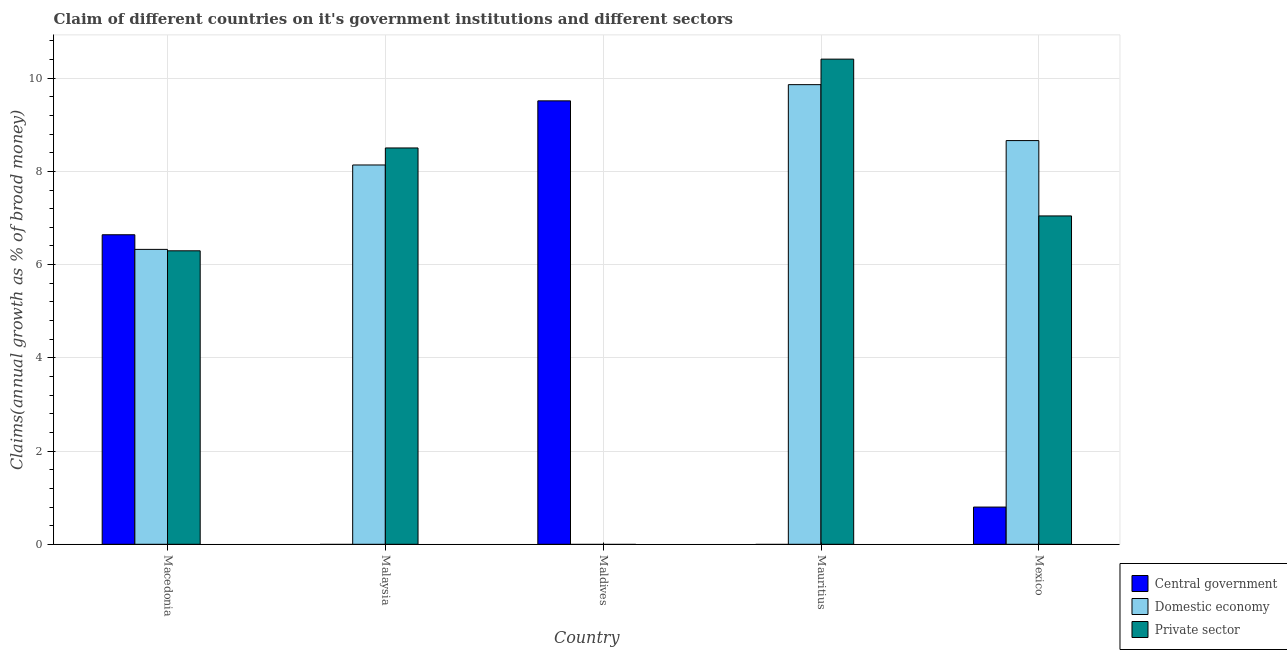Are the number of bars per tick equal to the number of legend labels?
Your answer should be very brief. No. How many bars are there on the 1st tick from the left?
Provide a short and direct response. 3. What is the label of the 1st group of bars from the left?
Provide a succinct answer. Macedonia. Across all countries, what is the maximum percentage of claim on the domestic economy?
Give a very brief answer. 9.86. In which country was the percentage of claim on the private sector maximum?
Ensure brevity in your answer.  Mauritius. What is the total percentage of claim on the domestic economy in the graph?
Your answer should be very brief. 32.98. What is the difference between the percentage of claim on the private sector in Malaysia and that in Mexico?
Offer a very short reply. 1.46. What is the difference between the percentage of claim on the domestic economy in Malaysia and the percentage of claim on the private sector in Macedonia?
Provide a short and direct response. 1.84. What is the average percentage of claim on the private sector per country?
Provide a short and direct response. 6.45. What is the difference between the percentage of claim on the central government and percentage of claim on the domestic economy in Mexico?
Offer a terse response. -7.86. In how many countries, is the percentage of claim on the central government greater than 8 %?
Your answer should be compact. 1. What is the ratio of the percentage of claim on the central government in Macedonia to that in Mexico?
Your answer should be very brief. 8.32. Is the difference between the percentage of claim on the private sector in Macedonia and Malaysia greater than the difference between the percentage of claim on the domestic economy in Macedonia and Malaysia?
Provide a short and direct response. No. What is the difference between the highest and the second highest percentage of claim on the private sector?
Give a very brief answer. 1.91. What is the difference between the highest and the lowest percentage of claim on the central government?
Keep it short and to the point. 9.51. How many bars are there?
Provide a succinct answer. 11. Are all the bars in the graph horizontal?
Provide a succinct answer. No. Are the values on the major ticks of Y-axis written in scientific E-notation?
Provide a short and direct response. No. Does the graph contain grids?
Offer a terse response. Yes. Where does the legend appear in the graph?
Make the answer very short. Bottom right. How many legend labels are there?
Make the answer very short. 3. What is the title of the graph?
Your answer should be compact. Claim of different countries on it's government institutions and different sectors. Does "Profit Tax" appear as one of the legend labels in the graph?
Ensure brevity in your answer.  No. What is the label or title of the X-axis?
Ensure brevity in your answer.  Country. What is the label or title of the Y-axis?
Offer a terse response. Claims(annual growth as % of broad money). What is the Claims(annual growth as % of broad money) of Central government in Macedonia?
Offer a terse response. 6.64. What is the Claims(annual growth as % of broad money) of Domestic economy in Macedonia?
Keep it short and to the point. 6.33. What is the Claims(annual growth as % of broad money) of Private sector in Macedonia?
Offer a very short reply. 6.3. What is the Claims(annual growth as % of broad money) of Domestic economy in Malaysia?
Your response must be concise. 8.14. What is the Claims(annual growth as % of broad money) in Private sector in Malaysia?
Provide a short and direct response. 8.5. What is the Claims(annual growth as % of broad money) in Central government in Maldives?
Provide a succinct answer. 9.51. What is the Claims(annual growth as % of broad money) of Central government in Mauritius?
Give a very brief answer. 0. What is the Claims(annual growth as % of broad money) in Domestic economy in Mauritius?
Your answer should be very brief. 9.86. What is the Claims(annual growth as % of broad money) of Private sector in Mauritius?
Offer a very short reply. 10.41. What is the Claims(annual growth as % of broad money) of Central government in Mexico?
Ensure brevity in your answer.  0.8. What is the Claims(annual growth as % of broad money) of Domestic economy in Mexico?
Give a very brief answer. 8.66. What is the Claims(annual growth as % of broad money) in Private sector in Mexico?
Make the answer very short. 7.04. Across all countries, what is the maximum Claims(annual growth as % of broad money) of Central government?
Your answer should be compact. 9.51. Across all countries, what is the maximum Claims(annual growth as % of broad money) in Domestic economy?
Your response must be concise. 9.86. Across all countries, what is the maximum Claims(annual growth as % of broad money) of Private sector?
Your answer should be very brief. 10.41. What is the total Claims(annual growth as % of broad money) of Central government in the graph?
Your response must be concise. 16.95. What is the total Claims(annual growth as % of broad money) of Domestic economy in the graph?
Ensure brevity in your answer.  32.98. What is the total Claims(annual growth as % of broad money) of Private sector in the graph?
Keep it short and to the point. 32.25. What is the difference between the Claims(annual growth as % of broad money) of Domestic economy in Macedonia and that in Malaysia?
Ensure brevity in your answer.  -1.81. What is the difference between the Claims(annual growth as % of broad money) of Private sector in Macedonia and that in Malaysia?
Make the answer very short. -2.21. What is the difference between the Claims(annual growth as % of broad money) in Central government in Macedonia and that in Maldives?
Offer a very short reply. -2.87. What is the difference between the Claims(annual growth as % of broad money) in Domestic economy in Macedonia and that in Mauritius?
Provide a short and direct response. -3.53. What is the difference between the Claims(annual growth as % of broad money) of Private sector in Macedonia and that in Mauritius?
Your answer should be compact. -4.11. What is the difference between the Claims(annual growth as % of broad money) in Central government in Macedonia and that in Mexico?
Your response must be concise. 5.84. What is the difference between the Claims(annual growth as % of broad money) in Domestic economy in Macedonia and that in Mexico?
Provide a succinct answer. -2.33. What is the difference between the Claims(annual growth as % of broad money) of Private sector in Macedonia and that in Mexico?
Provide a short and direct response. -0.75. What is the difference between the Claims(annual growth as % of broad money) in Domestic economy in Malaysia and that in Mauritius?
Ensure brevity in your answer.  -1.72. What is the difference between the Claims(annual growth as % of broad money) of Private sector in Malaysia and that in Mauritius?
Offer a very short reply. -1.91. What is the difference between the Claims(annual growth as % of broad money) in Domestic economy in Malaysia and that in Mexico?
Your response must be concise. -0.52. What is the difference between the Claims(annual growth as % of broad money) of Private sector in Malaysia and that in Mexico?
Give a very brief answer. 1.46. What is the difference between the Claims(annual growth as % of broad money) in Central government in Maldives and that in Mexico?
Your answer should be very brief. 8.71. What is the difference between the Claims(annual growth as % of broad money) in Private sector in Mauritius and that in Mexico?
Keep it short and to the point. 3.36. What is the difference between the Claims(annual growth as % of broad money) of Central government in Macedonia and the Claims(annual growth as % of broad money) of Domestic economy in Malaysia?
Offer a very short reply. -1.5. What is the difference between the Claims(annual growth as % of broad money) in Central government in Macedonia and the Claims(annual growth as % of broad money) in Private sector in Malaysia?
Offer a terse response. -1.86. What is the difference between the Claims(annual growth as % of broad money) of Domestic economy in Macedonia and the Claims(annual growth as % of broad money) of Private sector in Malaysia?
Provide a succinct answer. -2.18. What is the difference between the Claims(annual growth as % of broad money) of Central government in Macedonia and the Claims(annual growth as % of broad money) of Domestic economy in Mauritius?
Your response must be concise. -3.22. What is the difference between the Claims(annual growth as % of broad money) of Central government in Macedonia and the Claims(annual growth as % of broad money) of Private sector in Mauritius?
Provide a succinct answer. -3.77. What is the difference between the Claims(annual growth as % of broad money) of Domestic economy in Macedonia and the Claims(annual growth as % of broad money) of Private sector in Mauritius?
Ensure brevity in your answer.  -4.08. What is the difference between the Claims(annual growth as % of broad money) in Central government in Macedonia and the Claims(annual growth as % of broad money) in Domestic economy in Mexico?
Ensure brevity in your answer.  -2.02. What is the difference between the Claims(annual growth as % of broad money) in Central government in Macedonia and the Claims(annual growth as % of broad money) in Private sector in Mexico?
Make the answer very short. -0.4. What is the difference between the Claims(annual growth as % of broad money) of Domestic economy in Macedonia and the Claims(annual growth as % of broad money) of Private sector in Mexico?
Give a very brief answer. -0.72. What is the difference between the Claims(annual growth as % of broad money) of Domestic economy in Malaysia and the Claims(annual growth as % of broad money) of Private sector in Mauritius?
Provide a short and direct response. -2.27. What is the difference between the Claims(annual growth as % of broad money) of Domestic economy in Malaysia and the Claims(annual growth as % of broad money) of Private sector in Mexico?
Your answer should be compact. 1.09. What is the difference between the Claims(annual growth as % of broad money) in Central government in Maldives and the Claims(annual growth as % of broad money) in Domestic economy in Mauritius?
Your answer should be compact. -0.35. What is the difference between the Claims(annual growth as % of broad money) in Central government in Maldives and the Claims(annual growth as % of broad money) in Private sector in Mauritius?
Keep it short and to the point. -0.9. What is the difference between the Claims(annual growth as % of broad money) of Central government in Maldives and the Claims(annual growth as % of broad money) of Domestic economy in Mexico?
Keep it short and to the point. 0.85. What is the difference between the Claims(annual growth as % of broad money) in Central government in Maldives and the Claims(annual growth as % of broad money) in Private sector in Mexico?
Your answer should be compact. 2.47. What is the difference between the Claims(annual growth as % of broad money) of Domestic economy in Mauritius and the Claims(annual growth as % of broad money) of Private sector in Mexico?
Offer a very short reply. 2.82. What is the average Claims(annual growth as % of broad money) of Central government per country?
Your response must be concise. 3.39. What is the average Claims(annual growth as % of broad money) in Domestic economy per country?
Provide a short and direct response. 6.6. What is the average Claims(annual growth as % of broad money) in Private sector per country?
Offer a terse response. 6.45. What is the difference between the Claims(annual growth as % of broad money) in Central government and Claims(annual growth as % of broad money) in Domestic economy in Macedonia?
Provide a short and direct response. 0.31. What is the difference between the Claims(annual growth as % of broad money) of Central government and Claims(annual growth as % of broad money) of Private sector in Macedonia?
Your response must be concise. 0.34. What is the difference between the Claims(annual growth as % of broad money) of Domestic economy and Claims(annual growth as % of broad money) of Private sector in Macedonia?
Your answer should be compact. 0.03. What is the difference between the Claims(annual growth as % of broad money) in Domestic economy and Claims(annual growth as % of broad money) in Private sector in Malaysia?
Ensure brevity in your answer.  -0.36. What is the difference between the Claims(annual growth as % of broad money) in Domestic economy and Claims(annual growth as % of broad money) in Private sector in Mauritius?
Make the answer very short. -0.55. What is the difference between the Claims(annual growth as % of broad money) in Central government and Claims(annual growth as % of broad money) in Domestic economy in Mexico?
Offer a very short reply. -7.86. What is the difference between the Claims(annual growth as % of broad money) in Central government and Claims(annual growth as % of broad money) in Private sector in Mexico?
Your response must be concise. -6.25. What is the difference between the Claims(annual growth as % of broad money) in Domestic economy and Claims(annual growth as % of broad money) in Private sector in Mexico?
Give a very brief answer. 1.62. What is the ratio of the Claims(annual growth as % of broad money) of Domestic economy in Macedonia to that in Malaysia?
Ensure brevity in your answer.  0.78. What is the ratio of the Claims(annual growth as % of broad money) in Private sector in Macedonia to that in Malaysia?
Offer a terse response. 0.74. What is the ratio of the Claims(annual growth as % of broad money) of Central government in Macedonia to that in Maldives?
Ensure brevity in your answer.  0.7. What is the ratio of the Claims(annual growth as % of broad money) in Domestic economy in Macedonia to that in Mauritius?
Ensure brevity in your answer.  0.64. What is the ratio of the Claims(annual growth as % of broad money) in Private sector in Macedonia to that in Mauritius?
Keep it short and to the point. 0.6. What is the ratio of the Claims(annual growth as % of broad money) in Central government in Macedonia to that in Mexico?
Keep it short and to the point. 8.32. What is the ratio of the Claims(annual growth as % of broad money) of Domestic economy in Macedonia to that in Mexico?
Give a very brief answer. 0.73. What is the ratio of the Claims(annual growth as % of broad money) in Private sector in Macedonia to that in Mexico?
Make the answer very short. 0.89. What is the ratio of the Claims(annual growth as % of broad money) in Domestic economy in Malaysia to that in Mauritius?
Provide a short and direct response. 0.83. What is the ratio of the Claims(annual growth as % of broad money) of Private sector in Malaysia to that in Mauritius?
Provide a short and direct response. 0.82. What is the ratio of the Claims(annual growth as % of broad money) of Domestic economy in Malaysia to that in Mexico?
Offer a terse response. 0.94. What is the ratio of the Claims(annual growth as % of broad money) of Private sector in Malaysia to that in Mexico?
Provide a succinct answer. 1.21. What is the ratio of the Claims(annual growth as % of broad money) of Central government in Maldives to that in Mexico?
Your response must be concise. 11.91. What is the ratio of the Claims(annual growth as % of broad money) in Domestic economy in Mauritius to that in Mexico?
Your answer should be compact. 1.14. What is the ratio of the Claims(annual growth as % of broad money) in Private sector in Mauritius to that in Mexico?
Offer a very short reply. 1.48. What is the difference between the highest and the second highest Claims(annual growth as % of broad money) in Central government?
Give a very brief answer. 2.87. What is the difference between the highest and the second highest Claims(annual growth as % of broad money) of Domestic economy?
Make the answer very short. 1.2. What is the difference between the highest and the second highest Claims(annual growth as % of broad money) in Private sector?
Provide a short and direct response. 1.91. What is the difference between the highest and the lowest Claims(annual growth as % of broad money) of Central government?
Offer a terse response. 9.51. What is the difference between the highest and the lowest Claims(annual growth as % of broad money) in Domestic economy?
Offer a terse response. 9.86. What is the difference between the highest and the lowest Claims(annual growth as % of broad money) in Private sector?
Give a very brief answer. 10.41. 